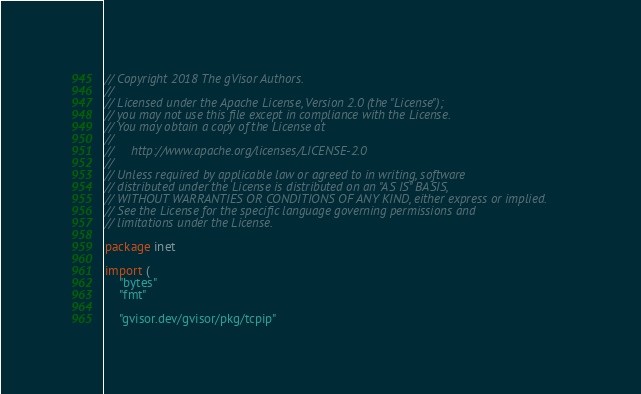<code> <loc_0><loc_0><loc_500><loc_500><_Go_>// Copyright 2018 The gVisor Authors.
//
// Licensed under the Apache License, Version 2.0 (the "License");
// you may not use this file except in compliance with the License.
// You may obtain a copy of the License at
//
//     http://www.apache.org/licenses/LICENSE-2.0
//
// Unless required by applicable law or agreed to in writing, software
// distributed under the License is distributed on an "AS IS" BASIS,
// WITHOUT WARRANTIES OR CONDITIONS OF ANY KIND, either express or implied.
// See the License for the specific language governing permissions and
// limitations under the License.

package inet

import (
	"bytes"
	"fmt"

	"gvisor.dev/gvisor/pkg/tcpip"</code> 